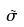Convert formula to latex. <formula><loc_0><loc_0><loc_500><loc_500>\tilde { \sigma }</formula> 